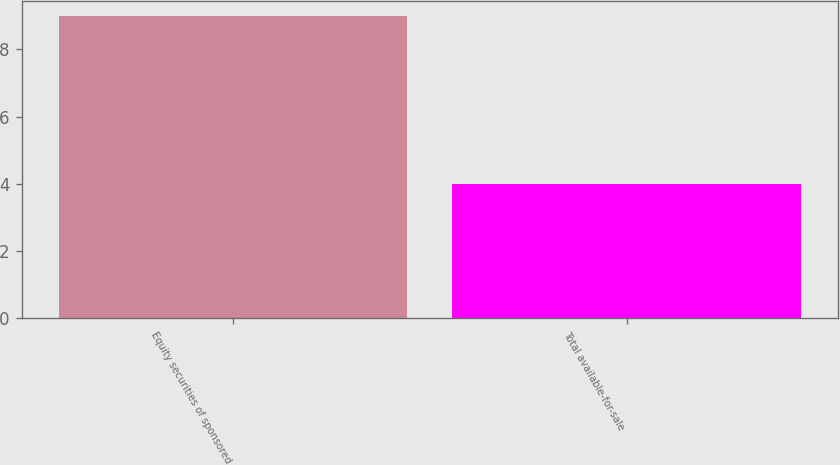Convert chart. <chart><loc_0><loc_0><loc_500><loc_500><bar_chart><fcel>Equity securities of sponsored<fcel>Total available-for-sale<nl><fcel>9<fcel>4<nl></chart> 